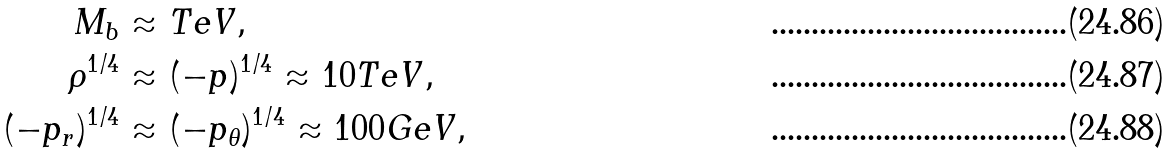<formula> <loc_0><loc_0><loc_500><loc_500>M _ { b } & \approx T e V , \\ \rho ^ { 1 / 4 } & \approx ( - p ) ^ { 1 / 4 } \approx 1 0 T e V , \\ ( - p _ { r } ) ^ { 1 / 4 } & \approx ( - p _ { \theta } ) ^ { 1 / 4 } \approx 1 0 0 G e V ,</formula> 